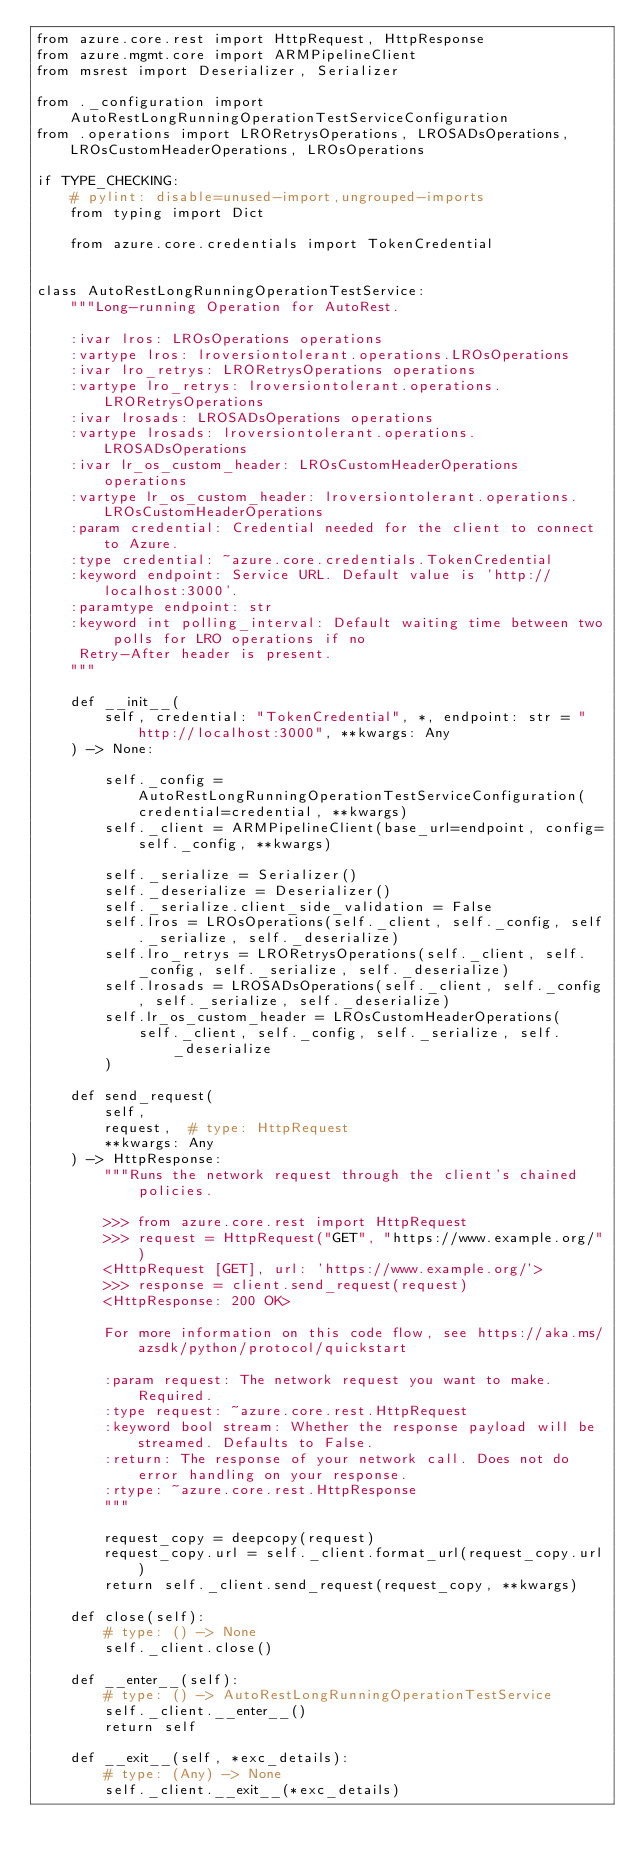<code> <loc_0><loc_0><loc_500><loc_500><_Python_>from azure.core.rest import HttpRequest, HttpResponse
from azure.mgmt.core import ARMPipelineClient
from msrest import Deserializer, Serializer

from ._configuration import AutoRestLongRunningOperationTestServiceConfiguration
from .operations import LRORetrysOperations, LROSADsOperations, LROsCustomHeaderOperations, LROsOperations

if TYPE_CHECKING:
    # pylint: disable=unused-import,ungrouped-imports
    from typing import Dict

    from azure.core.credentials import TokenCredential


class AutoRestLongRunningOperationTestService:
    """Long-running Operation for AutoRest.

    :ivar lros: LROsOperations operations
    :vartype lros: lroversiontolerant.operations.LROsOperations
    :ivar lro_retrys: LRORetrysOperations operations
    :vartype lro_retrys: lroversiontolerant.operations.LRORetrysOperations
    :ivar lrosads: LROSADsOperations operations
    :vartype lrosads: lroversiontolerant.operations.LROSADsOperations
    :ivar lr_os_custom_header: LROsCustomHeaderOperations operations
    :vartype lr_os_custom_header: lroversiontolerant.operations.LROsCustomHeaderOperations
    :param credential: Credential needed for the client to connect to Azure.
    :type credential: ~azure.core.credentials.TokenCredential
    :keyword endpoint: Service URL. Default value is 'http://localhost:3000'.
    :paramtype endpoint: str
    :keyword int polling_interval: Default waiting time between two polls for LRO operations if no
     Retry-After header is present.
    """

    def __init__(
        self, credential: "TokenCredential", *, endpoint: str = "http://localhost:3000", **kwargs: Any
    ) -> None:

        self._config = AutoRestLongRunningOperationTestServiceConfiguration(credential=credential, **kwargs)
        self._client = ARMPipelineClient(base_url=endpoint, config=self._config, **kwargs)

        self._serialize = Serializer()
        self._deserialize = Deserializer()
        self._serialize.client_side_validation = False
        self.lros = LROsOperations(self._client, self._config, self._serialize, self._deserialize)
        self.lro_retrys = LRORetrysOperations(self._client, self._config, self._serialize, self._deserialize)
        self.lrosads = LROSADsOperations(self._client, self._config, self._serialize, self._deserialize)
        self.lr_os_custom_header = LROsCustomHeaderOperations(
            self._client, self._config, self._serialize, self._deserialize
        )

    def send_request(
        self,
        request,  # type: HttpRequest
        **kwargs: Any
    ) -> HttpResponse:
        """Runs the network request through the client's chained policies.

        >>> from azure.core.rest import HttpRequest
        >>> request = HttpRequest("GET", "https://www.example.org/")
        <HttpRequest [GET], url: 'https://www.example.org/'>
        >>> response = client.send_request(request)
        <HttpResponse: 200 OK>

        For more information on this code flow, see https://aka.ms/azsdk/python/protocol/quickstart

        :param request: The network request you want to make. Required.
        :type request: ~azure.core.rest.HttpRequest
        :keyword bool stream: Whether the response payload will be streamed. Defaults to False.
        :return: The response of your network call. Does not do error handling on your response.
        :rtype: ~azure.core.rest.HttpResponse
        """

        request_copy = deepcopy(request)
        request_copy.url = self._client.format_url(request_copy.url)
        return self._client.send_request(request_copy, **kwargs)

    def close(self):
        # type: () -> None
        self._client.close()

    def __enter__(self):
        # type: () -> AutoRestLongRunningOperationTestService
        self._client.__enter__()
        return self

    def __exit__(self, *exc_details):
        # type: (Any) -> None
        self._client.__exit__(*exc_details)
</code> 